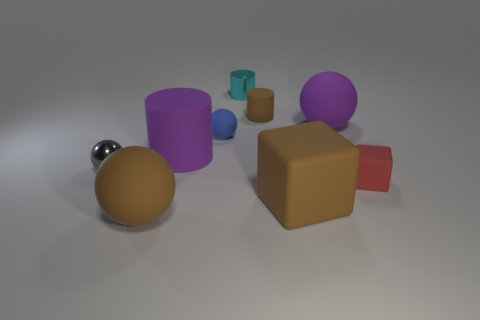How would you describe the different textures seen on the objects? The objects display a variety of textures: the metallic cylinder and sphere have a high-gloss finish that reflects light sharply, suggesting a smooth texture. In contrast, the purple and blue objects have a matte surface, indicating a less reflective, likely slightly rougher texture. The brown cube and the gold sphere have a satiny texture, not as reflective as metal but with a slight sheen that suggests a smoother surface than the matte objects. 